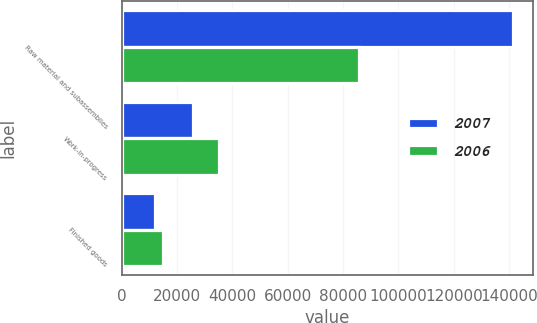<chart> <loc_0><loc_0><loc_500><loc_500><stacked_bar_chart><ecel><fcel>Raw material and subassemblies<fcel>Work-in-progress<fcel>Finished goods<nl><fcel>2007<fcel>141521<fcel>25885<fcel>11960<nl><fcel>2006<fcel>85860<fcel>35057<fcel>15011<nl></chart> 